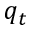<formula> <loc_0><loc_0><loc_500><loc_500>q _ { t }</formula> 